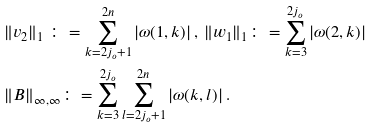<formula> <loc_0><loc_0><loc_500><loc_500>& \| v _ { 2 } \| _ { 1 } \ \colon = \sum _ { k = 2 j _ { o } + 1 } ^ { 2 n } | \omega ( 1 , k ) | \, , \, \| w _ { 1 } \| _ { 1 } \colon = \sum _ { k = 3 } ^ { 2 j _ { o } } | \omega ( 2 , k ) | \\ & \| B \| _ { \infty , \infty } \colon = \sum _ { k = 3 } ^ { 2 j _ { o } } \sum _ { l = 2 j _ { o } + 1 } ^ { 2 n } | \omega ( k , l ) | \, .</formula> 